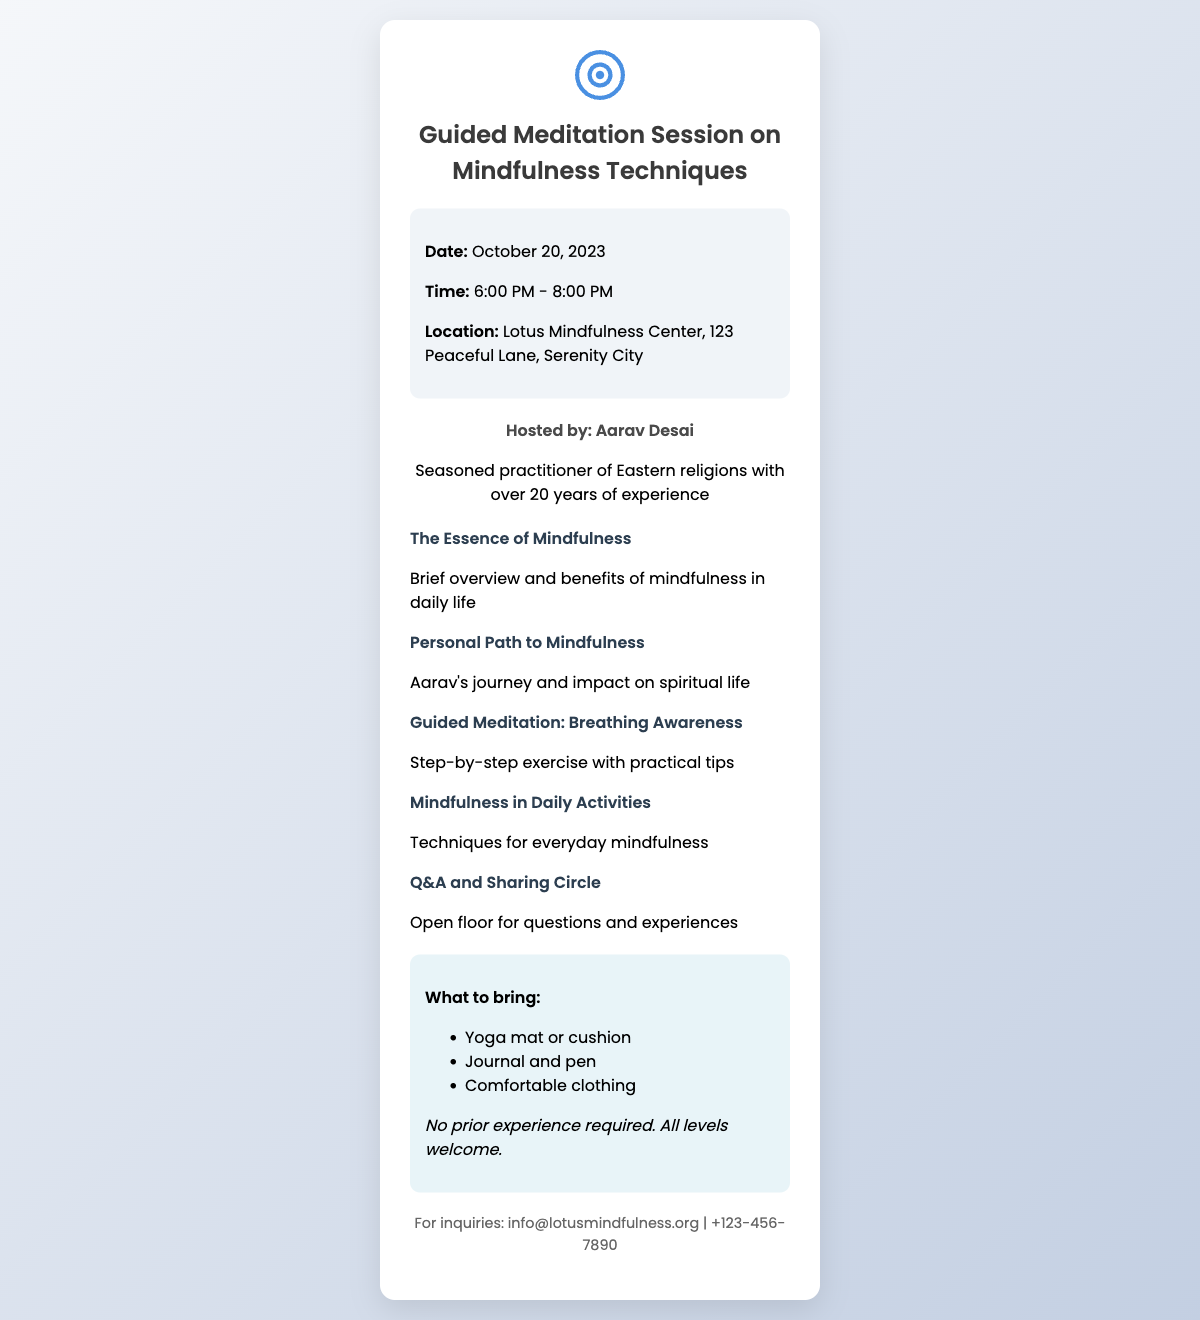What is the date of the session? The date of the session is specified in the event details section of the ticket.
Answer: October 20, 2023 What time does the session start? The start time is mentioned alongside the date in the event details.
Answer: 6:00 PM Where is the venue located? The location is stated in the event details section.
Answer: Lotus Mindfulness Center, 123 Peaceful Lane, Serenity City Who is the host of the session? The host's name is given in the host details section of the document.
Answer: Aarav Desai What is one activity included in the session outline? The session outline lists multiple segments, and one can be identified as an activity.
Answer: Guided Meditation: Breathing Awareness Is prior experience required to attend? The additional info section mentions experience requirements for participants.
Answer: No What is one item participants should bring? The what to bring section specifies items participants should have.
Answer: Yoga mat or cushion 